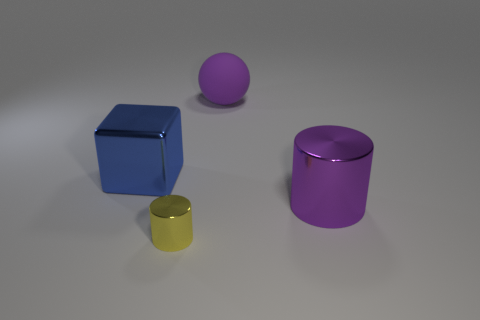Is there any other thing that is the same size as the yellow metallic object?
Your answer should be compact. No. Are there any other things that have the same material as the large ball?
Make the answer very short. No. What material is the large thing that is on the left side of the ball?
Make the answer very short. Metal. There is a large thing that is both to the left of the purple cylinder and on the right side of the large metallic cube; what material is it?
Offer a terse response. Rubber. Is the size of the purple matte sphere to the right of the blue cube the same as the block?
Make the answer very short. Yes. What is the shape of the small metal thing?
Provide a short and direct response. Cylinder. What number of tiny yellow shiny objects are the same shape as the purple shiny thing?
Offer a terse response. 1. What number of large objects are in front of the blue thing and to the left of the tiny thing?
Make the answer very short. 0. What is the color of the large metallic block?
Offer a very short reply. Blue. Is there a big blue cylinder that has the same material as the big purple cylinder?
Give a very brief answer. No. 